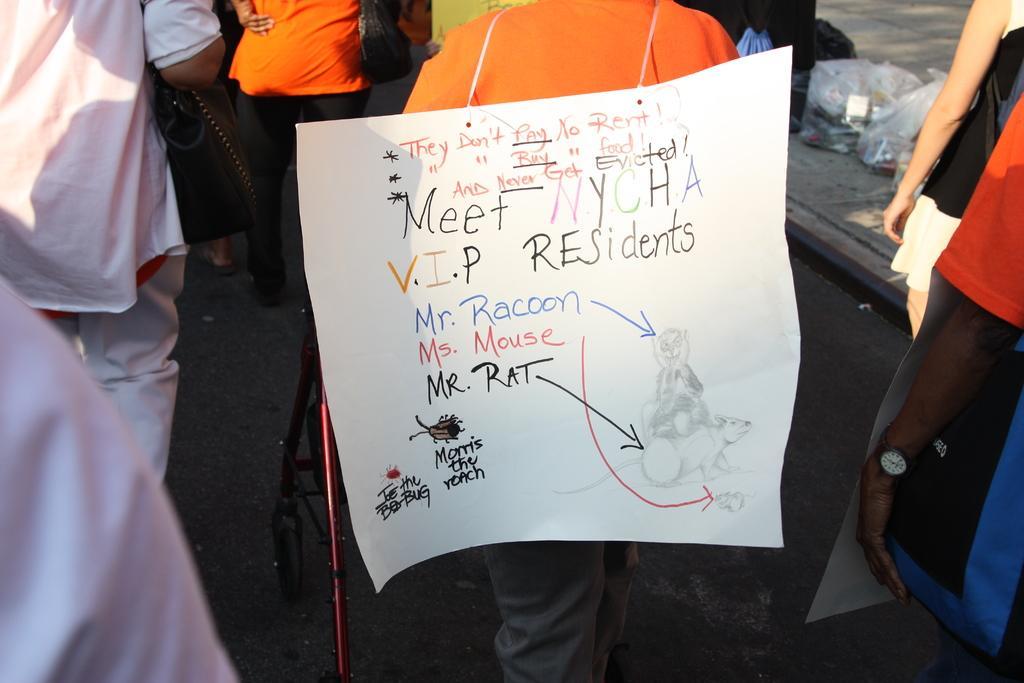In one or two sentences, can you explain what this image depicts? In this image we can see a poster with some text on the back of a person. On the both sides of the image, we can see people. We can see some carry bags on the pavement in the right top of the image. 